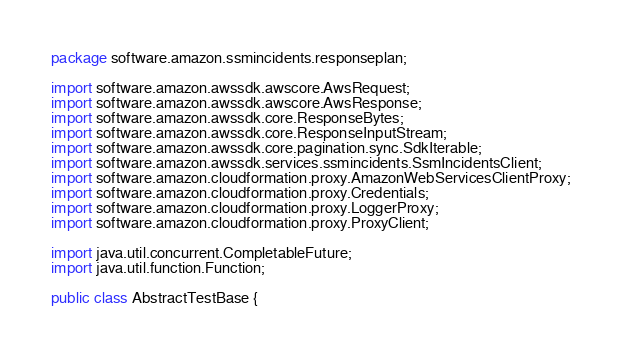Convert code to text. <code><loc_0><loc_0><loc_500><loc_500><_Java_>package software.amazon.ssmincidents.responseplan;

import software.amazon.awssdk.awscore.AwsRequest;
import software.amazon.awssdk.awscore.AwsResponse;
import software.amazon.awssdk.core.ResponseBytes;
import software.amazon.awssdk.core.ResponseInputStream;
import software.amazon.awssdk.core.pagination.sync.SdkIterable;
import software.amazon.awssdk.services.ssmincidents.SsmIncidentsClient;
import software.amazon.cloudformation.proxy.AmazonWebServicesClientProxy;
import software.amazon.cloudformation.proxy.Credentials;
import software.amazon.cloudformation.proxy.LoggerProxy;
import software.amazon.cloudformation.proxy.ProxyClient;

import java.util.concurrent.CompletableFuture;
import java.util.function.Function;

public class AbstractTestBase {
</code> 